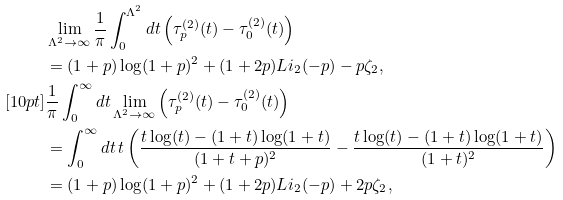<formula> <loc_0><loc_0><loc_500><loc_500>& \lim _ { \Lambda ^ { 2 } \to \infty } \frac { 1 } { \pi } \int _ { 0 } ^ { \Lambda ^ { 2 } } d t \left ( \tau _ { p } ^ { ( 2 ) } ( t ) - \tau _ { 0 } ^ { ( 2 ) } ( t ) \right ) \\ & = ( 1 + p ) \log ( 1 + p ) ^ { 2 } + ( 1 + 2 p ) L i _ { 2 } ( - p ) - p \zeta _ { 2 } , \\ [ 1 0 p t ] & \frac { 1 } { \pi } \int _ { 0 } ^ { \infty } d t \lim _ { \Lambda ^ { 2 } \to \infty } \left ( \tau _ { p } ^ { ( 2 ) } ( t ) - \tau _ { 0 } ^ { ( 2 ) } ( t ) \right ) \\ & = \int _ { 0 } ^ { \infty } d t \, t \left ( \frac { t \log ( t ) - ( 1 + t ) \log ( 1 + t ) } { ( 1 + t + p ) ^ { 2 } } - \frac { t \log ( t ) - ( 1 + t ) \log ( 1 + t ) } { ( 1 + t ) ^ { 2 } } \right ) \\ & = ( 1 + p ) \log ( 1 + p ) ^ { 2 } + ( 1 + 2 p ) L i _ { 2 } ( - p ) + 2 p \zeta _ { 2 } ,</formula> 